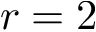Convert formula to latex. <formula><loc_0><loc_0><loc_500><loc_500>r = 2</formula> 